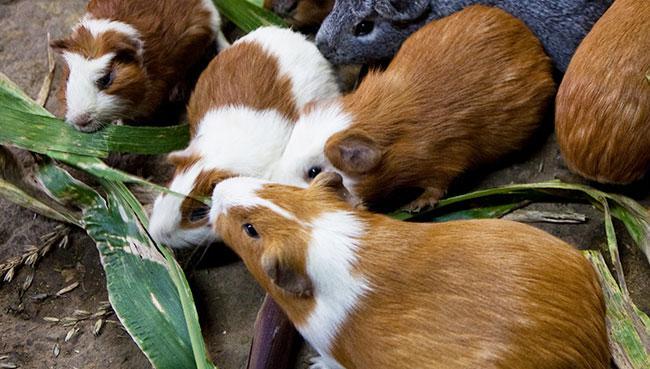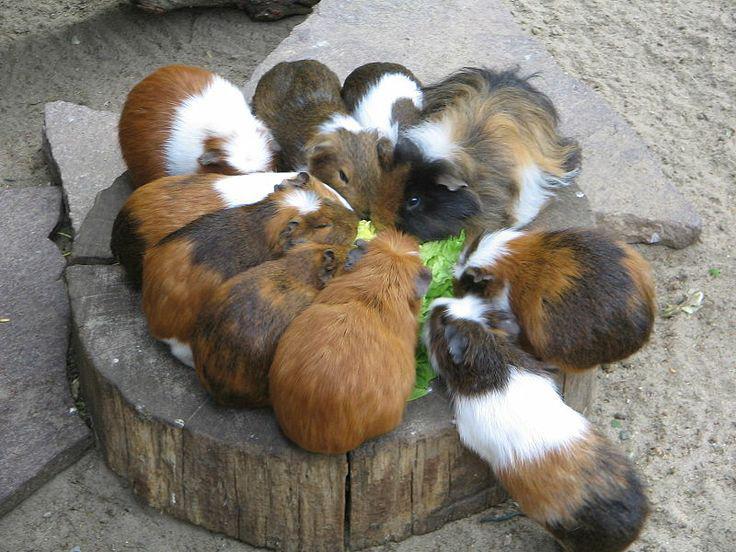The first image is the image on the left, the second image is the image on the right. Evaluate the accuracy of this statement regarding the images: "There are at least six guinea pigs.". Is it true? Answer yes or no. Yes. The first image is the image on the left, the second image is the image on the right. Assess this claim about the two images: "There are no more than four guinea pigs". Correct or not? Answer yes or no. No. 